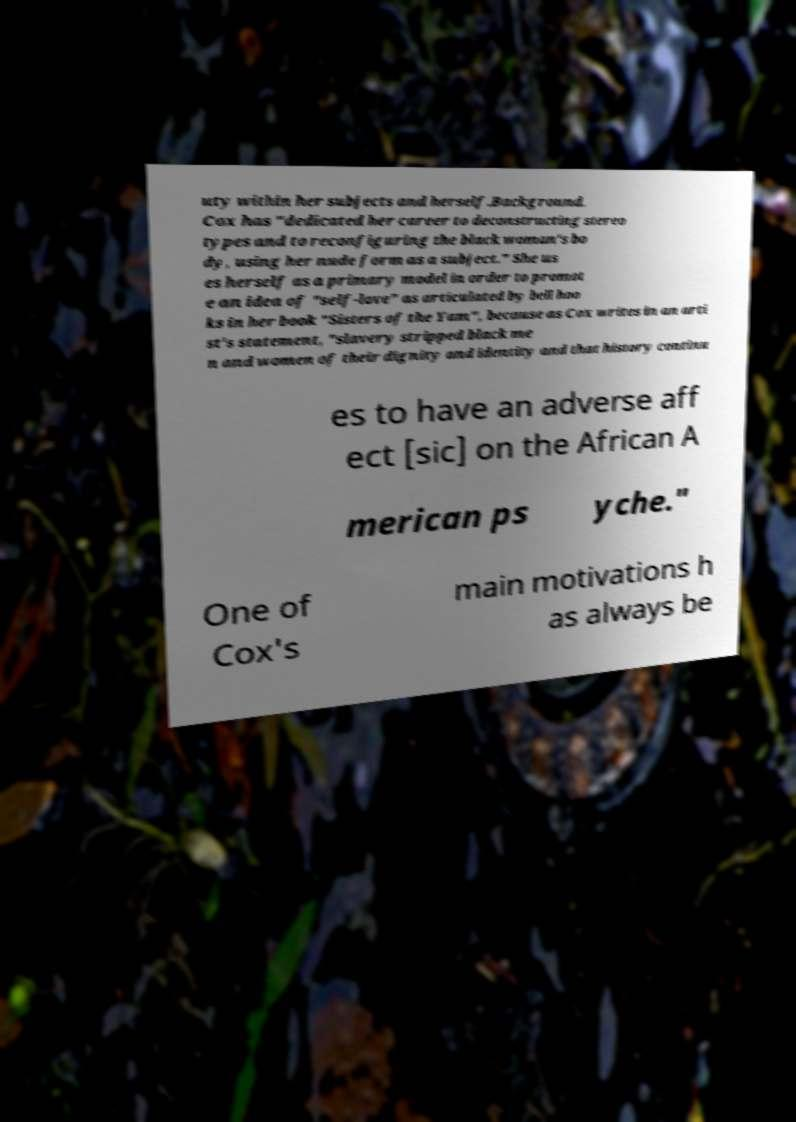What messages or text are displayed in this image? I need them in a readable, typed format. uty within her subjects and herself.Background. Cox has "dedicated her career to deconstructing stereo types and to reconfiguring the black woman's bo dy, using her nude form as a subject." She us es herself as a primary model in order to promot e an idea of "self-love" as articulated by bell hoo ks in her book "Sisters of the Yam", because as Cox writes in an arti st's statement, "slavery stripped black me n and women of their dignity and identity and that history continu es to have an adverse aff ect [sic] on the African A merican ps yche." One of Cox's main motivations h as always be 